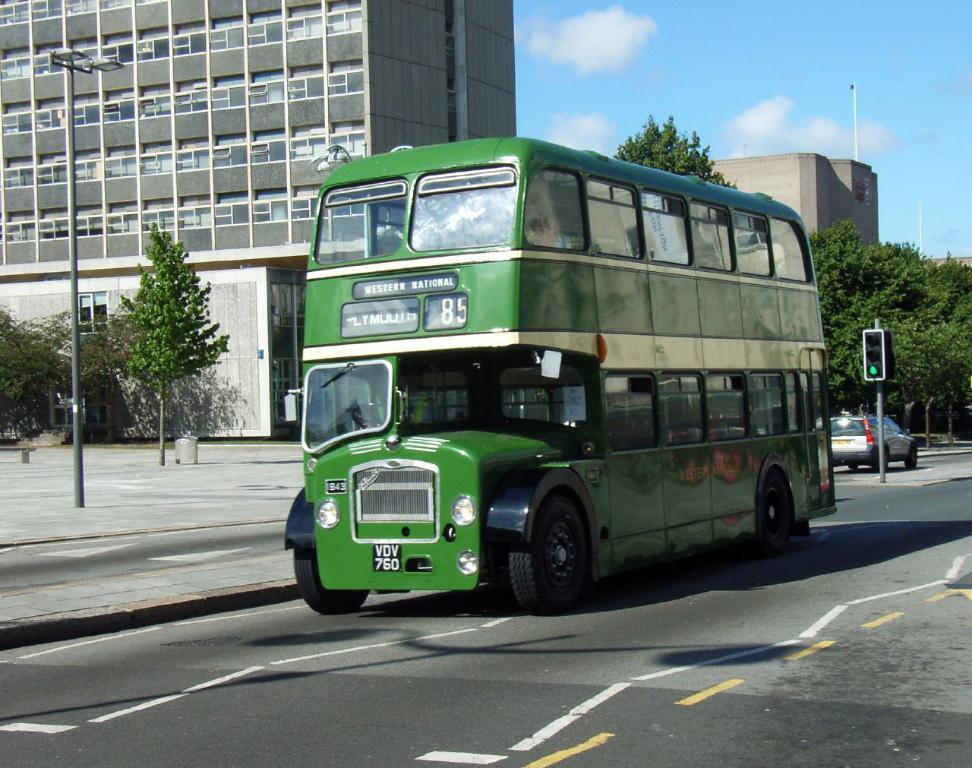What type of vehicle is in the image? There is a green bus in the image. What is at the bottom of the image? There is a road at the bottom of the image. What can be seen in the background of the image? There are buildings in the background of the image. What type of vegetation is on the right side of the image? There are trees to the right of the image. What type of mint is growing on the bus in the image? There is no mint growing on the bus in the image; it is a green bus without any plants. 